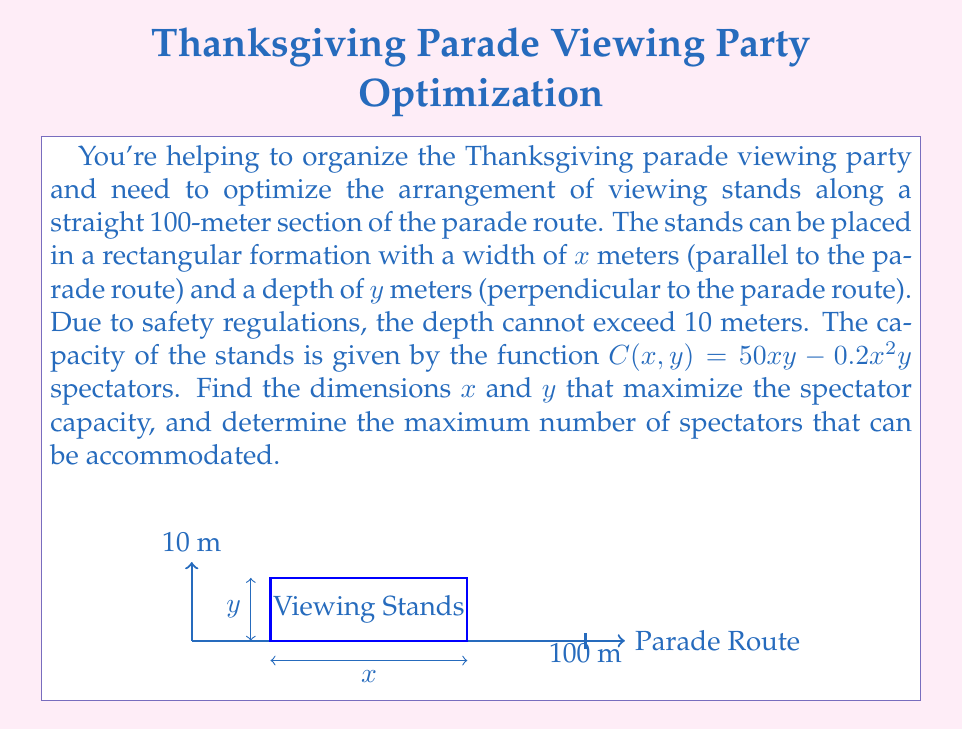Provide a solution to this math problem. Let's approach this problem step-by-step using multivariable calculus:

1) The objective function is $C(x,y) = 50xy - 0.2x^2y$, subject to the constraints:
   $0 \leq x \leq 100$ (length of the section)
   $0 \leq y \leq 10$ (maximum depth allowed)

2) To find the maximum, we need to find the critical points by taking partial derivatives:

   $$\frac{\partial C}{\partial x} = 50y - 0.4xy$$
   $$\frac{\partial C}{\partial y} = 50x - 0.2x^2$$

3) Set these equal to zero and solve:

   $50y - 0.4xy = 0$
   $50x - 0.2x^2 = 0$

4) From the second equation:
   $x(50 - 0.2x) = 0$
   $x = 0$ or $x = 250$

   Since $x = 250$ is outside our constraint, we focus on the interior points.

5) From the first equation:
   $50y - 0.4xy = 0$
   $y(50 - 0.4x) = 0$
   $y = 0$ or $x = 125$

6) Combining these results, we have a critical point at $(125, 0)$, which is outside our constraints.

7) Since there are no critical points within the constraints, the maximum must occur on the boundary. We need to check:
   - The corners: $(0,0)$, $(0,10)$, $(100,0)$, $(100,10)$
   - The edges: $y=10$ and $x=100$

8) Evaluating $C(x,y)$ at the corners:
   $C(0,0) = C(0,10) = C(100,0) = 0$
   $C(100,10) = 50(100)(10) - 0.2(100)^2(10) = 30000$

9) For the edge $y=10$:
   $C(x,10) = 500x - 2x^2$
   Maximizing this: $\frac{d}{dx}(500x - 2x^2) = 500 - 4x = 0$
   $x = 125$, which is outside our constraint.
   The maximum on this edge occurs at $x=100$.

10) For the edge $x=100$:
    $C(100,y) = 5000y - 2000y = 3000y$
    This is maximized when $y$ is at its maximum, 10.

Therefore, the maximum occurs at $(100,10)$, which we already calculated to be 30000 spectators.
Answer: $x = 100$ m, $y = 10$ m, maximum capacity = 30000 spectators 